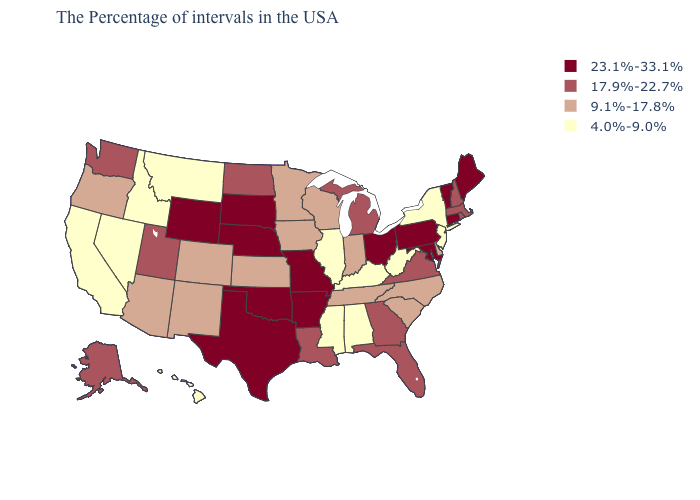Does South Carolina have the highest value in the USA?
Be succinct. No. What is the value of Hawaii?
Short answer required. 4.0%-9.0%. Which states have the lowest value in the Northeast?
Concise answer only. New York, New Jersey. What is the value of Mississippi?
Keep it brief. 4.0%-9.0%. What is the highest value in the USA?
Answer briefly. 23.1%-33.1%. What is the value of Mississippi?
Write a very short answer. 4.0%-9.0%. How many symbols are there in the legend?
Quick response, please. 4. Name the states that have a value in the range 9.1%-17.8%?
Quick response, please. Delaware, North Carolina, South Carolina, Indiana, Tennessee, Wisconsin, Minnesota, Iowa, Kansas, Colorado, New Mexico, Arizona, Oregon. How many symbols are there in the legend?
Give a very brief answer. 4. What is the highest value in states that border Florida?
Quick response, please. 17.9%-22.7%. Does Pennsylvania have the lowest value in the USA?
Concise answer only. No. Does the first symbol in the legend represent the smallest category?
Quick response, please. No. Among the states that border Kansas , which have the lowest value?
Give a very brief answer. Colorado. What is the value of Vermont?
Keep it brief. 23.1%-33.1%. What is the highest value in states that border Indiana?
Write a very short answer. 23.1%-33.1%. 